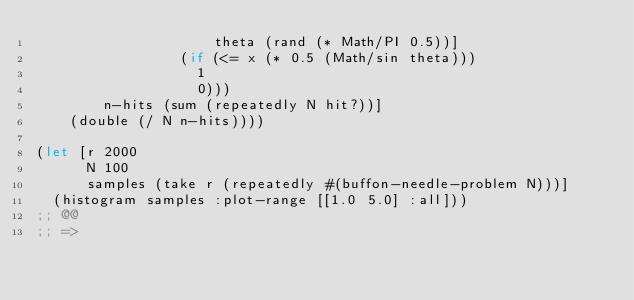<code> <loc_0><loc_0><loc_500><loc_500><_Clojure_>                     theta (rand (* Math/PI 0.5))]
                 (if (<= x (* 0.5 (Math/sin theta)))
                   1
                   0)))
        n-hits (sum (repeatedly N hit?))]
    (double (/ N n-hits))))

(let [r 2000
      N 100
      samples (take r (repeatedly #(buffon-needle-problem N)))]
  (histogram samples :plot-range [[1.0 5.0] :all]))
;; @@
;; =></code> 